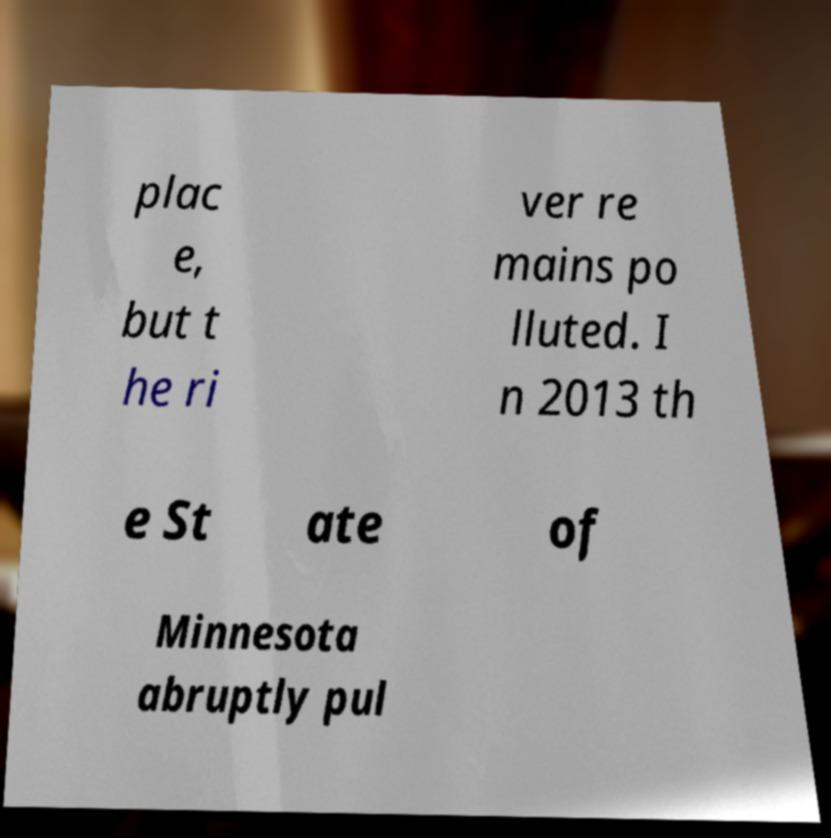Could you extract and type out the text from this image? plac e, but t he ri ver re mains po lluted. I n 2013 th e St ate of Minnesota abruptly pul 